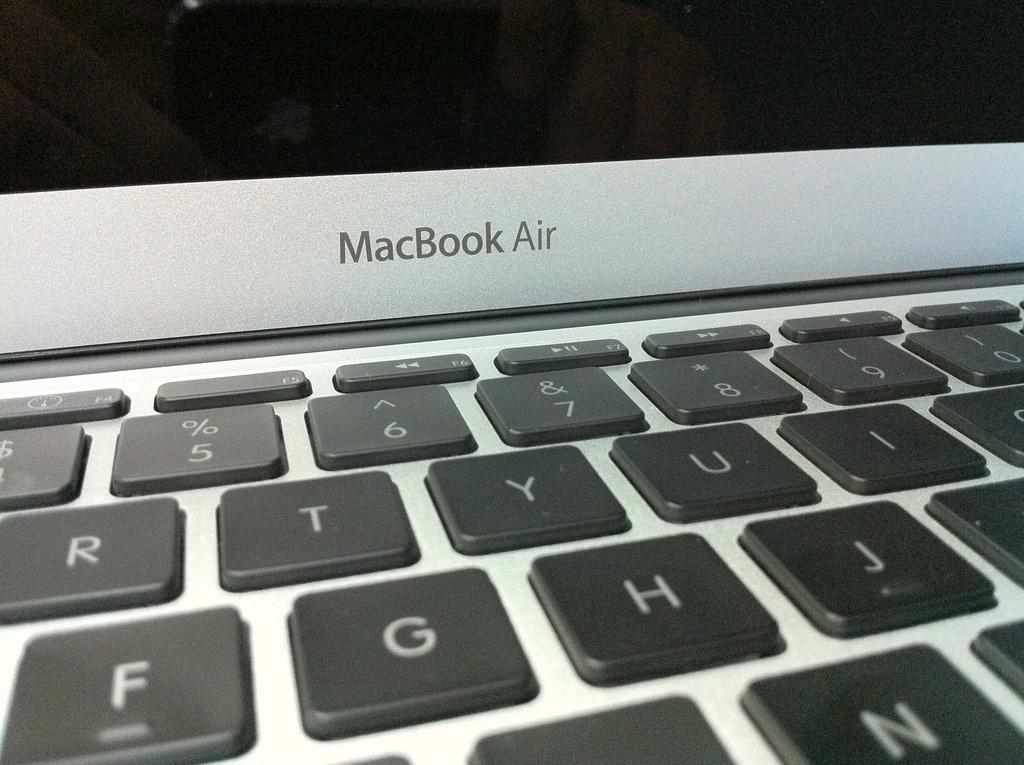<image>
Offer a succinct explanation of the picture presented. A MacBook Air is open revealing black keys on a silver laptop. 